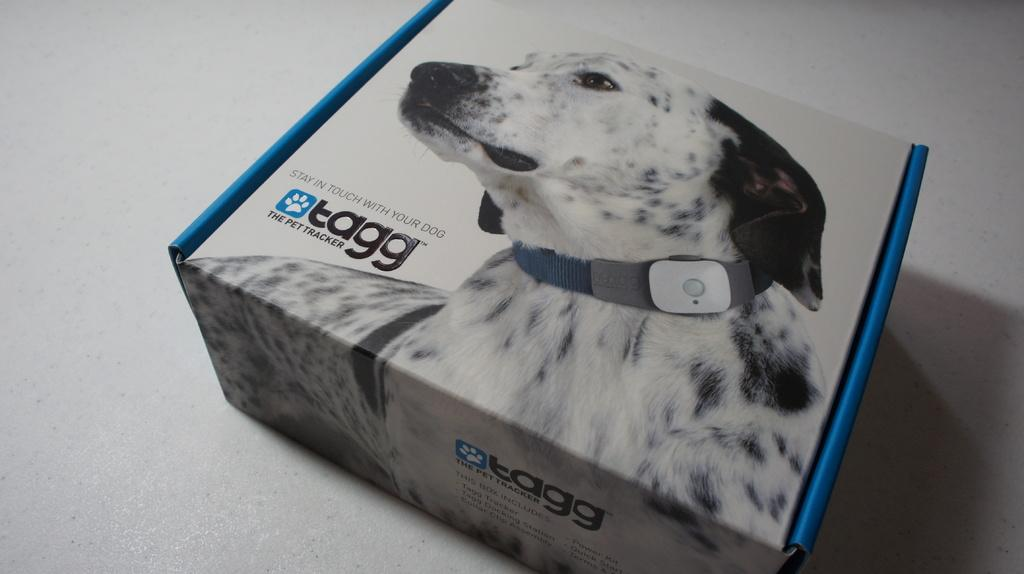<image>
Present a compact description of the photo's key features. Box with a dog on the front that contains a tagg pet tracker 